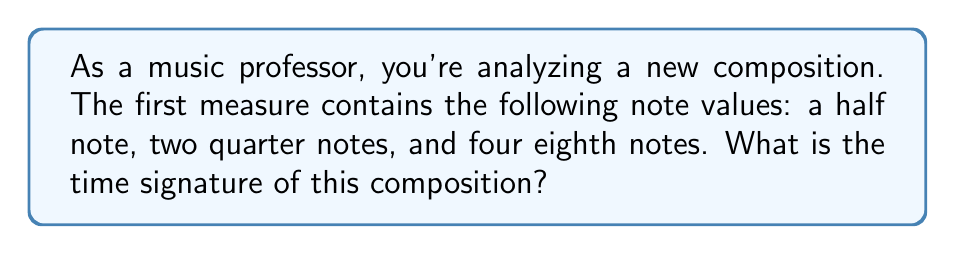Could you help me with this problem? To determine the time signature, we need to calculate the total number of beats in the measure and identify the note value that represents one beat. Let's break this down step-by-step:

1. First, let's recall the relative durations of different note values:
   - Whole note = 4 beats
   - Half note = 2 beats
   - Quarter note = 1 beat
   - Eighth note = 1/2 beat

2. Now, let's count the beats in the measure:
   - Half note: 2 beats
   - Two quarter notes: $2 \times 1 = 2$ beats
   - Four eighth notes: $4 \times \frac{1}{2} = 2$ beats

3. Total number of beats: $2 + 2 + 2 = 6$ beats

4. In most common time signatures, the quarter note gets one beat. Since we have 6 beats in total, and the quarter note is present in the measure, we can conclude that the time signature is 6/4.

5. To verify, let's check if all the notes fit into a 6/4 measure:
   $$(2) + (1 + 1) + (\frac{1}{2} + \frac{1}{2} + \frac{1}{2} + \frac{1}{2}) = 6$$

Thus, the time signature that accommodates all these note values in one measure is 6/4.
Answer: The time signature of the composition is 6/4. 